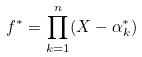<formula> <loc_0><loc_0><loc_500><loc_500>f ^ { * } = \prod _ { k = 1 } ^ { n } ( X - \alpha _ { k } ^ { * } )</formula> 